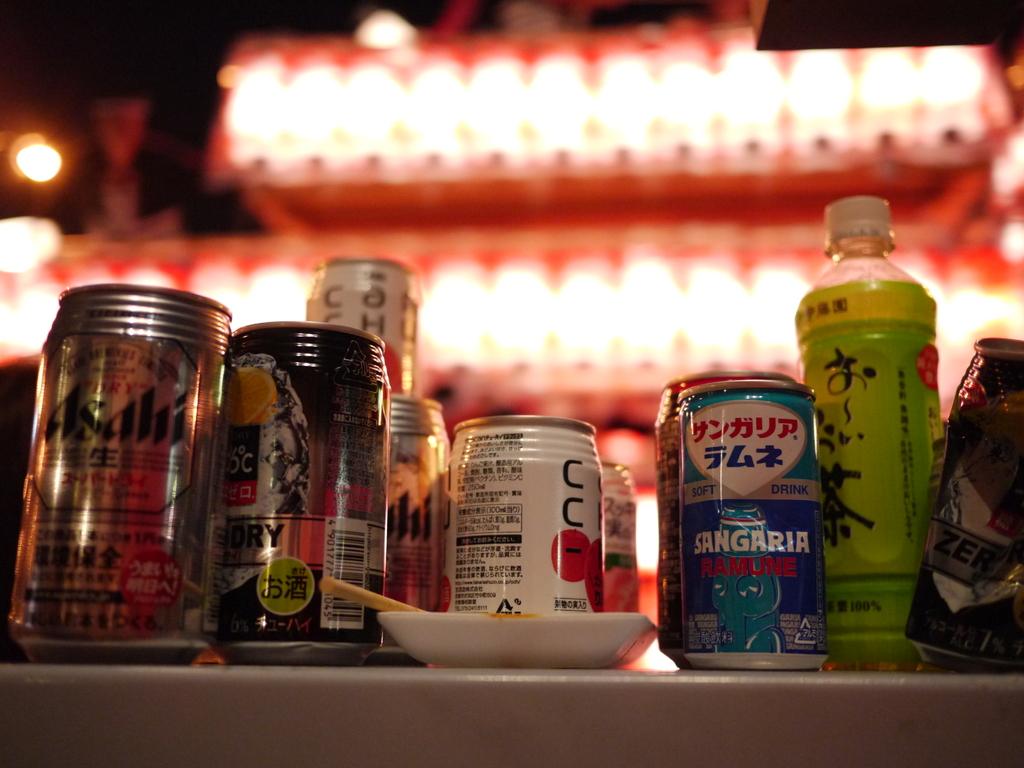What beverage is in the blue can?
Ensure brevity in your answer.  Sangaria. 